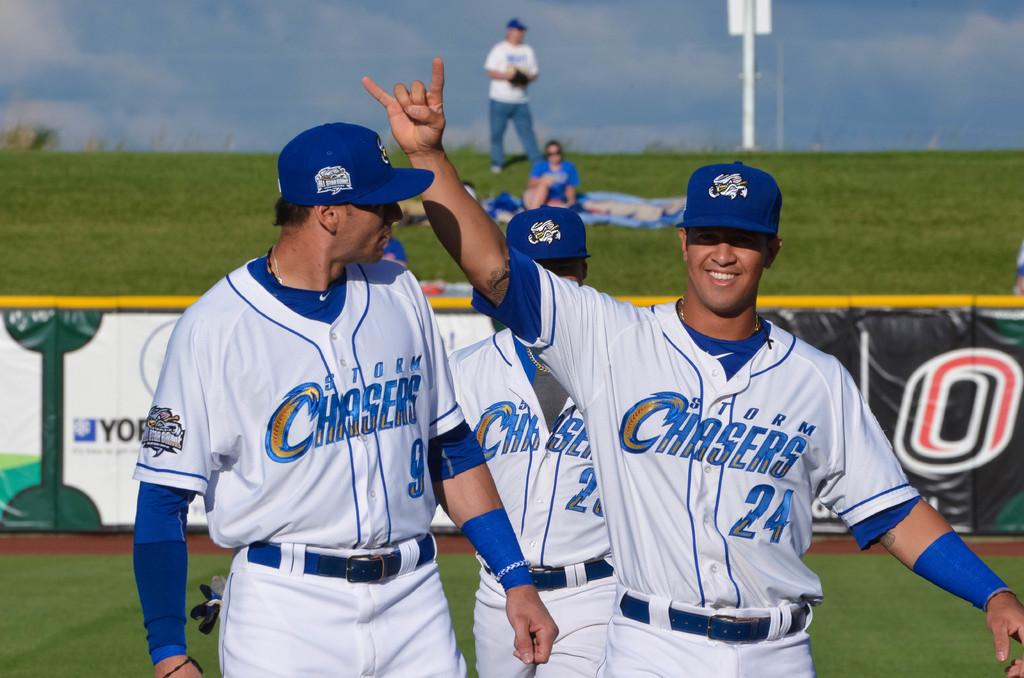<image>
Summarize the visual content of the image. Some sportsmen in blue and white with Chasers on their shirts. 